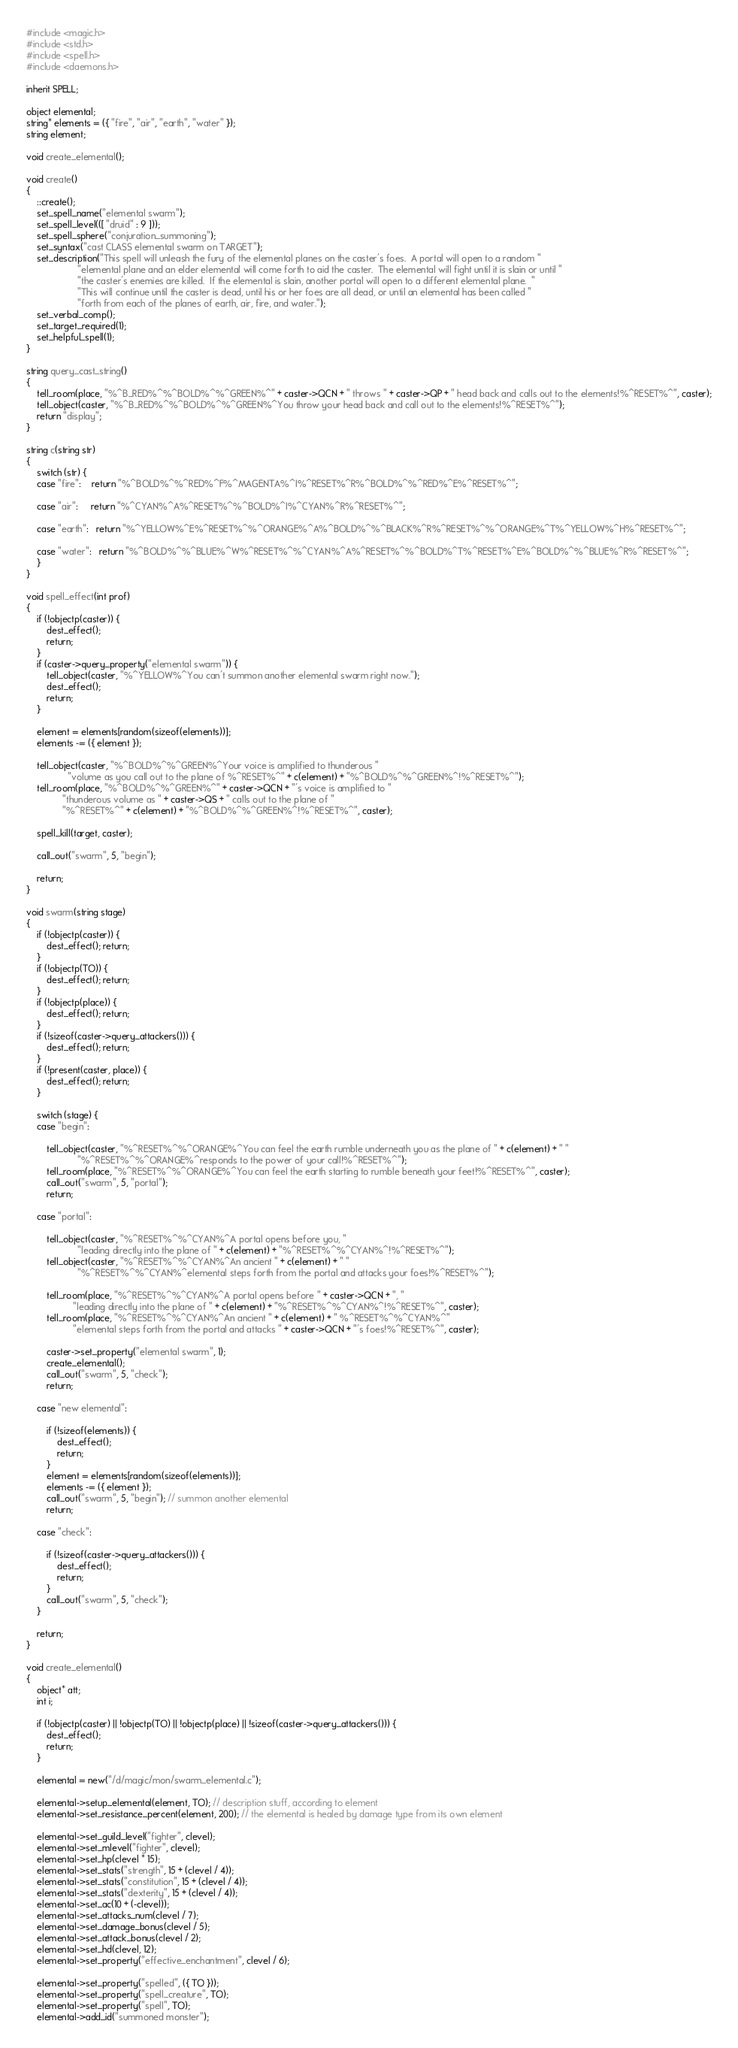Convert code to text. <code><loc_0><loc_0><loc_500><loc_500><_C_>#include <magic.h>
#include <std.h>
#include <spell.h>
#include <daemons.h>

inherit SPELL;

object elemental;
string* elements = ({ "fire", "air", "earth", "water" });
string element;

void create_elemental();

void create()
{
    ::create();
    set_spell_name("elemental swarm");
    set_spell_level(([ "druid" : 9 ]));
    set_spell_sphere("conjuration_summoning");
    set_syntax("cast CLASS elemental swarm on TARGET");
    set_description("This spell will unleash the fury of the elemental planes on the caster's foes.  A portal will open to a random "
                    "elemental plane and an elder elemental will come forth to aid the caster.  The elemental will fight until it is slain or until "
                    "the caster's enemies are killed.  If the elemental is slain, another portal will open to a different elemental plane.  "
                    "This will continue until the caster is dead, until his or her foes are all dead, or until an elemental has been called "
                    "forth from each of the planes of earth, air, fire, and water.");
    set_verbal_comp();
    set_target_required(1);
    set_helpful_spell(1);
}

string query_cast_string()
{
    tell_room(place, "%^B_RED%^%^BOLD%^%^GREEN%^" + caster->QCN + " throws " + caster->QP + " head back and calls out to the elements!%^RESET%^", caster);
    tell_object(caster, "%^B_RED%^%^BOLD%^%^GREEN%^You throw your head back and call out to the elements!%^RESET%^");
    return "display";
}

string c(string str)
{
    switch (str) {
    case "fire":    return "%^BOLD%^%^RED%^F%^MAGENTA%^I%^RESET%^R%^BOLD%^%^RED%^E%^RESET%^";

    case "air":     return "%^CYAN%^A%^RESET%^%^BOLD%^I%^CYAN%^R%^RESET%^";

    case "earth":   return "%^YELLOW%^E%^RESET%^%^ORANGE%^A%^BOLD%^%^BLACK%^R%^RESET%^%^ORANGE%^T%^YELLOW%^H%^RESET%^";

    case "water":   return "%^BOLD%^%^BLUE%^W%^RESET%^%^CYAN%^A%^RESET%^%^BOLD%^T%^RESET%^E%^BOLD%^%^BLUE%^R%^RESET%^";
    }
}

void spell_effect(int prof)
{
    if (!objectp(caster)) {
        dest_effect();
        return;
    }
    if (caster->query_property("elemental swarm")) {
        tell_object(caster, "%^YELLOW%^You can't summon another elemental swarm right now.");
        dest_effect();
        return;
    }

    element = elements[random(sizeof(elements))];
    elements -= ({ element });

    tell_object(caster, "%^BOLD%^%^GREEN%^Your voice is amplified to thunderous "
                "volume as you call out to the plane of %^RESET%^" + c(element) + "%^BOLD%^%^GREEN%^!%^RESET%^");
    tell_room(place, "%^BOLD%^%^GREEN%^" + caster->QCN + "'s voice is amplified to "
              "thunderous volume as " + caster->QS + " calls out to the plane of "
              "%^RESET%^" + c(element) + "%^BOLD%^%^GREEN%^!%^RESET%^", caster);

    spell_kill(target, caster);

    call_out("swarm", 5, "begin");

    return;
}

void swarm(string stage)
{
    if (!objectp(caster)) {
        dest_effect(); return;
    }
    if (!objectp(TO)) {
        dest_effect(); return;
    }
    if (!objectp(place)) {
        dest_effect(); return;
    }
    if (!sizeof(caster->query_attackers())) {
        dest_effect(); return;
    }
    if (!present(caster, place)) {
        dest_effect(); return;
    }

    switch (stage) {
    case "begin":

        tell_object(caster, "%^RESET%^%^ORANGE%^You can feel the earth rumble underneath you as the plane of " + c(element) + " "
                    "%^RESET%^%^ORANGE%^responds to the power of your call!%^RESET%^");
        tell_room(place, "%^RESET%^%^ORANGE%^You can feel the earth starting to rumble beneath your feet!%^RESET%^", caster);
        call_out("swarm", 5, "portal");
        return;

    case "portal":

        tell_object(caster, "%^RESET%^%^CYAN%^A portal opens before you, "
                    "leading directly into the plane of " + c(element) + "%^RESET%^%^CYAN%^!%^RESET%^");
        tell_object(caster, "%^RESET%^%^CYAN%^An ancient " + c(element) + " "
                    "%^RESET%^%^CYAN%^elemental steps forth from the portal and attacks your foes!%^RESET%^");

        tell_room(place, "%^RESET%^%^CYAN%^A portal opens before " + caster->QCN + ", "
                  "leading directly into the plane of " + c(element) + "%^RESET%^%^CYAN%^!%^RESET%^", caster);
        tell_room(place, "%^RESET%^%^CYAN%^An ancient " + c(element) + " %^RESET%^%^CYAN%^"
                  "elemental steps forth from the portal and attacks " + caster->QCN + "'s foes!%^RESET%^", caster);

        caster->set_property("elemental swarm", 1);
        create_elemental();
        call_out("swarm", 5, "check");
        return;

    case "new elemental":

        if (!sizeof(elements)) {
            dest_effect();
            return;
        }
        element = elements[random(sizeof(elements))];
        elements -= ({ element });
        call_out("swarm", 5, "begin"); // summon another elemental
        return;

    case "check":

        if (!sizeof(caster->query_attackers())) {
            dest_effect();
            return;
        }
        call_out("swarm", 5, "check");
    }

    return;
}

void create_elemental()
{
    object* att;
    int i;

    if (!objectp(caster) || !objectp(TO) || !objectp(place) || !sizeof(caster->query_attackers())) {
        dest_effect();
        return;
    }

    elemental = new("/d/magic/mon/swarm_elemental.c");

    elemental->setup_elemental(element, TO); // description stuff, according to element
    elemental->set_resistance_percent(element, 200); // the elemental is healed by damage type from its own element

    elemental->set_guild_level("fighter", clevel);
    elemental->set_mlevel("fighter", clevel);
    elemental->set_hp(clevel * 15);
    elemental->set_stats("strength", 15 + (clevel / 4));
    elemental->set_stats("constitution", 15 + (clevel / 4));
    elemental->set_stats("dexterity", 15 + (clevel / 4));
    elemental->set_ac(10 + (-clevel));
    elemental->set_attacks_num(clevel / 7);
    elemental->set_damage_bonus(clevel / 5);
    elemental->set_attack_bonus(clevel / 2);
    elemental->set_hd(clevel, 12);
    elemental->set_property("effective_enchantment", clevel / 6);

    elemental->set_property("spelled", ({ TO }));
    elemental->set_property("spell_creature", TO);
    elemental->set_property("spell", TO);
    elemental->add_id("summoned monster");</code> 